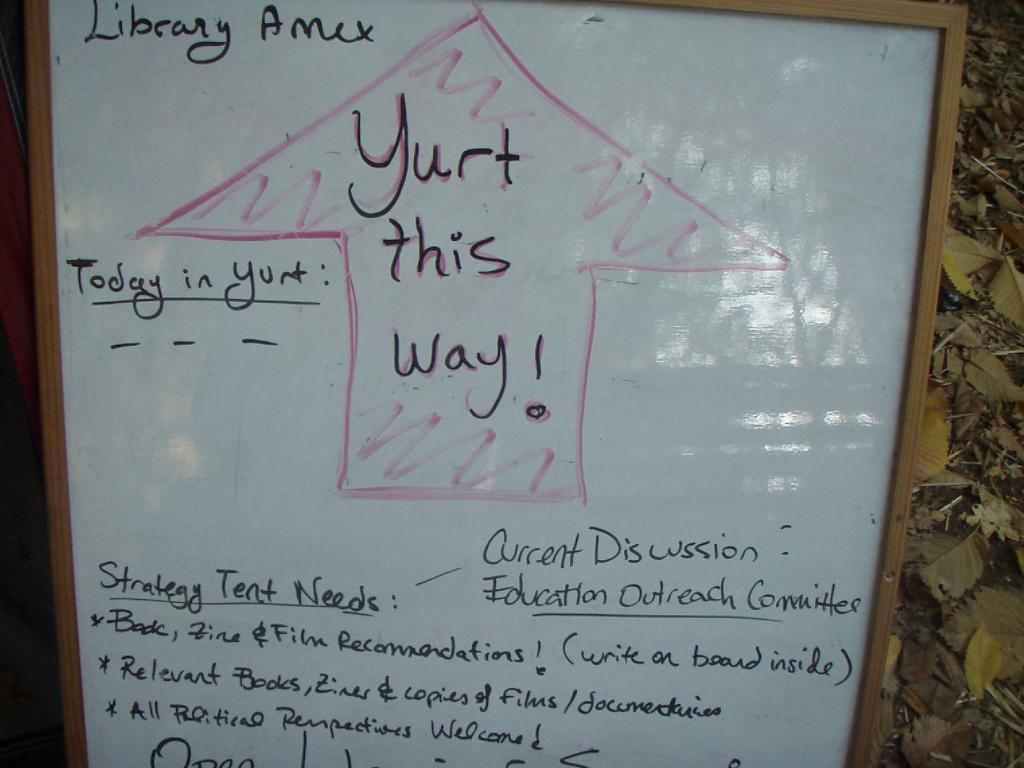<image>
Describe the image concisely. Library conference being announced on a white board with an arrow that says "Yurt this way!" 